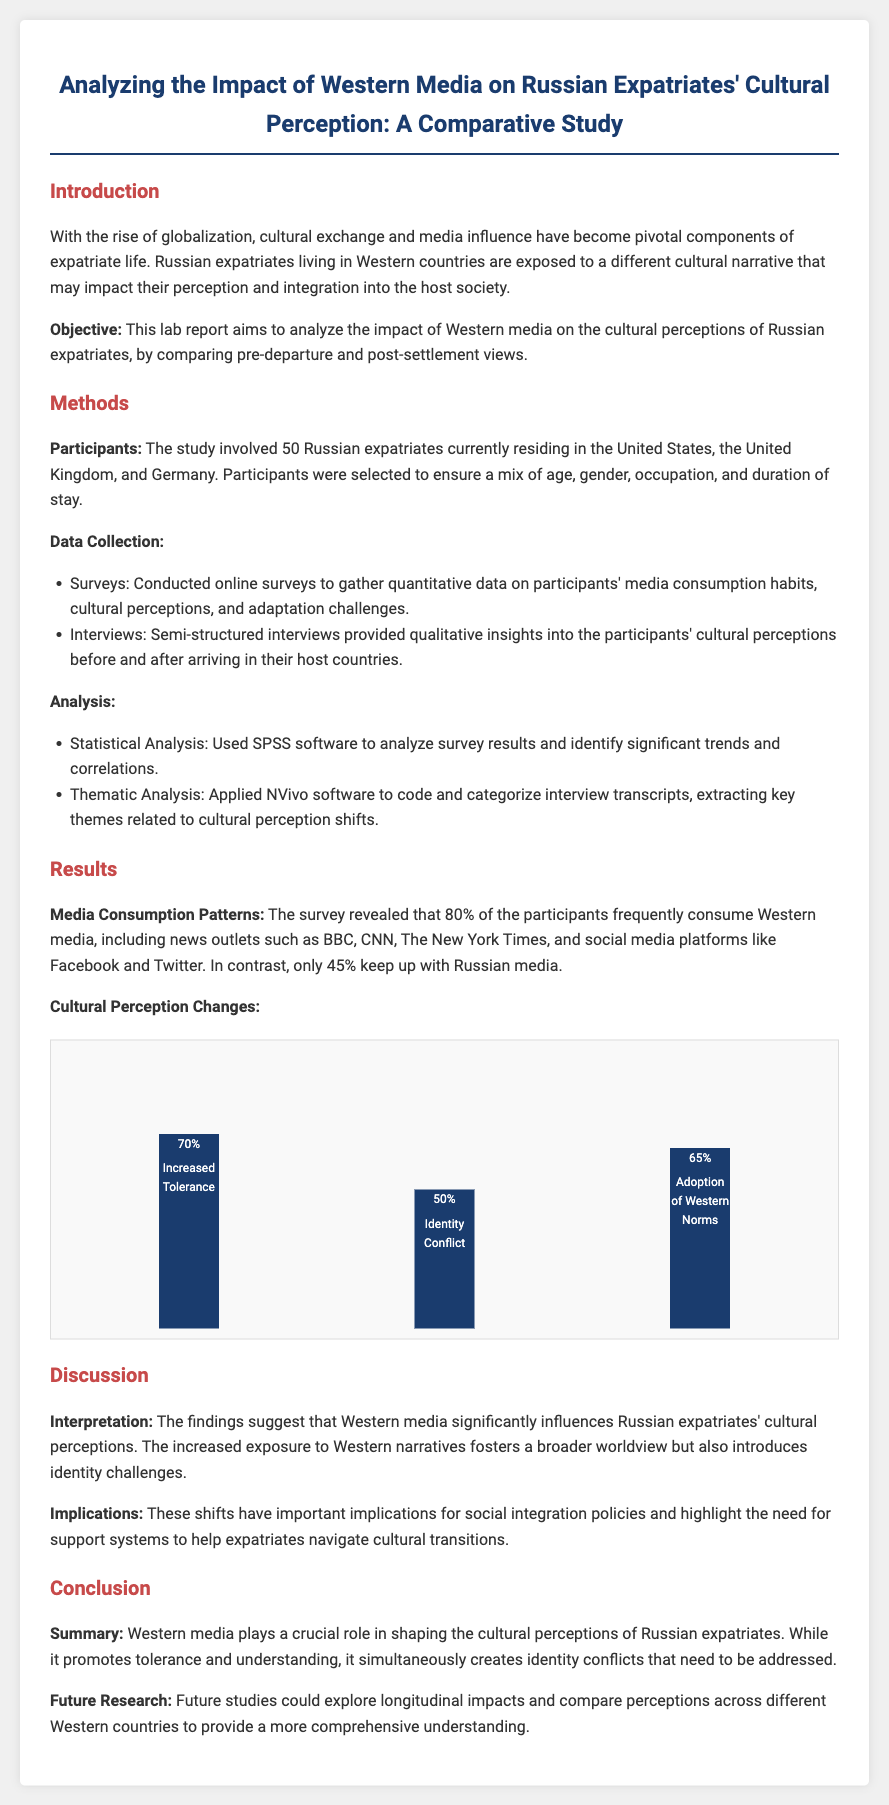what is the objective of the study? The objective is to analyze the impact of Western media on cultural perceptions of Russian expatriates, by comparing pre-departure and post-settlement views.
Answer: to analyze the impact of Western media on cultural perceptions how many participants were involved in the study? The document states that 50 Russian expatriates participated in the study.
Answer: 50 which countries were the participants residing in? The participants were residing in the United States, the United Kingdom, and Germany.
Answer: United States, United Kingdom, and Germany what percentage of participants frequently consume Western media? The survey revealed that 80% of the participants frequently consume Western media.
Answer: 80% what software was used for statistical analysis? The document mentions that SPSS software was used for statistical analysis.
Answer: SPSS what is the percentage of participants that experienced increased tolerance? The results indicate that 70% of the participants reported increased tolerance.
Answer: 70% what does the study suggest about the influence of Western media? The findings suggest that Western media significantly influences Russian expatriates' cultural perceptions.
Answer: significantly influences what future research is suggested in the report? The report suggests that future studies could explore longitudinal impacts and compare perceptions across different Western countries.
Answer: longitudinal impacts and compare perceptions across different Western countries 